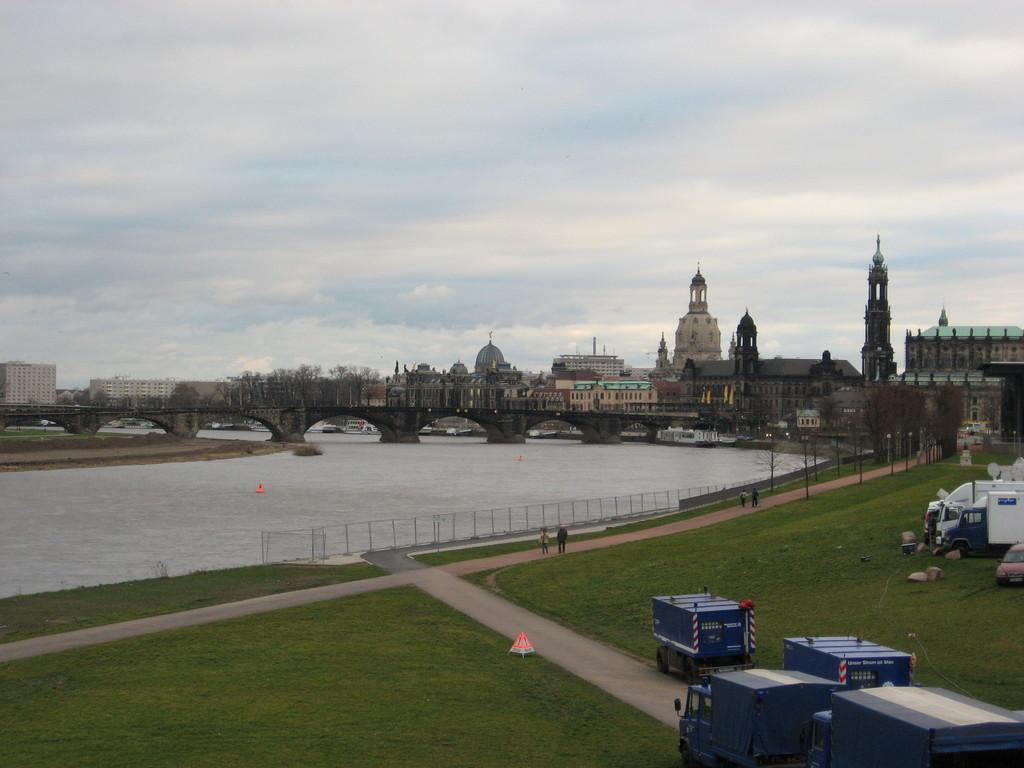What is the main feature in the center of the image? There is water in the center of the image. What type of vegetation can be seen on the ground in the front of the image? There is grass on the ground in the front of the image. What types of man-made objects are present in the image? There are vehicles and buildings in the image. What is the condition of the sky in the image? The sky is cloudy in the image. Can you tell me how many farmers are working in the grass in the image? There are no farmers present in the image; it features water, grass, vehicles, buildings, and a cloudy sky. What type of sugar can be seen growing on the stem in the image? There is no sugar or stem present in the image. 